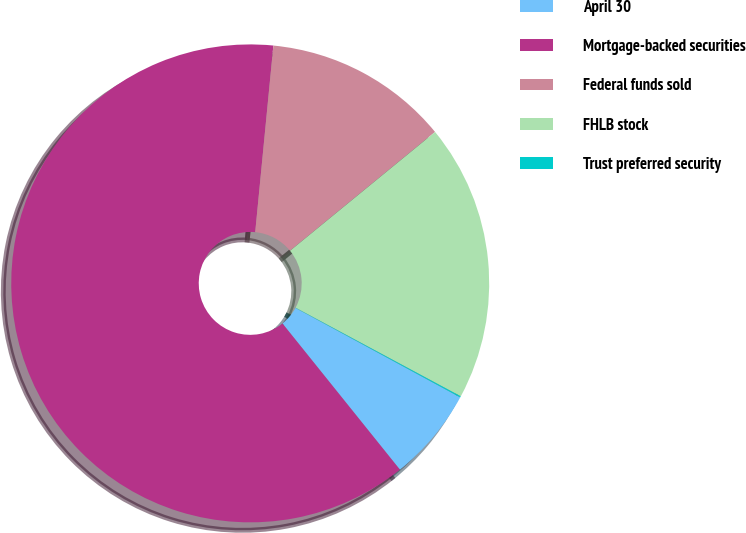Convert chart. <chart><loc_0><loc_0><loc_500><loc_500><pie_chart><fcel>April 30<fcel>Mortgage-backed securities<fcel>Federal funds sold<fcel>FHLB stock<fcel>Trust preferred security<nl><fcel>6.31%<fcel>62.32%<fcel>12.53%<fcel>18.76%<fcel>0.08%<nl></chart> 